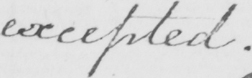Please transcribe the handwritten text in this image. excepted . 